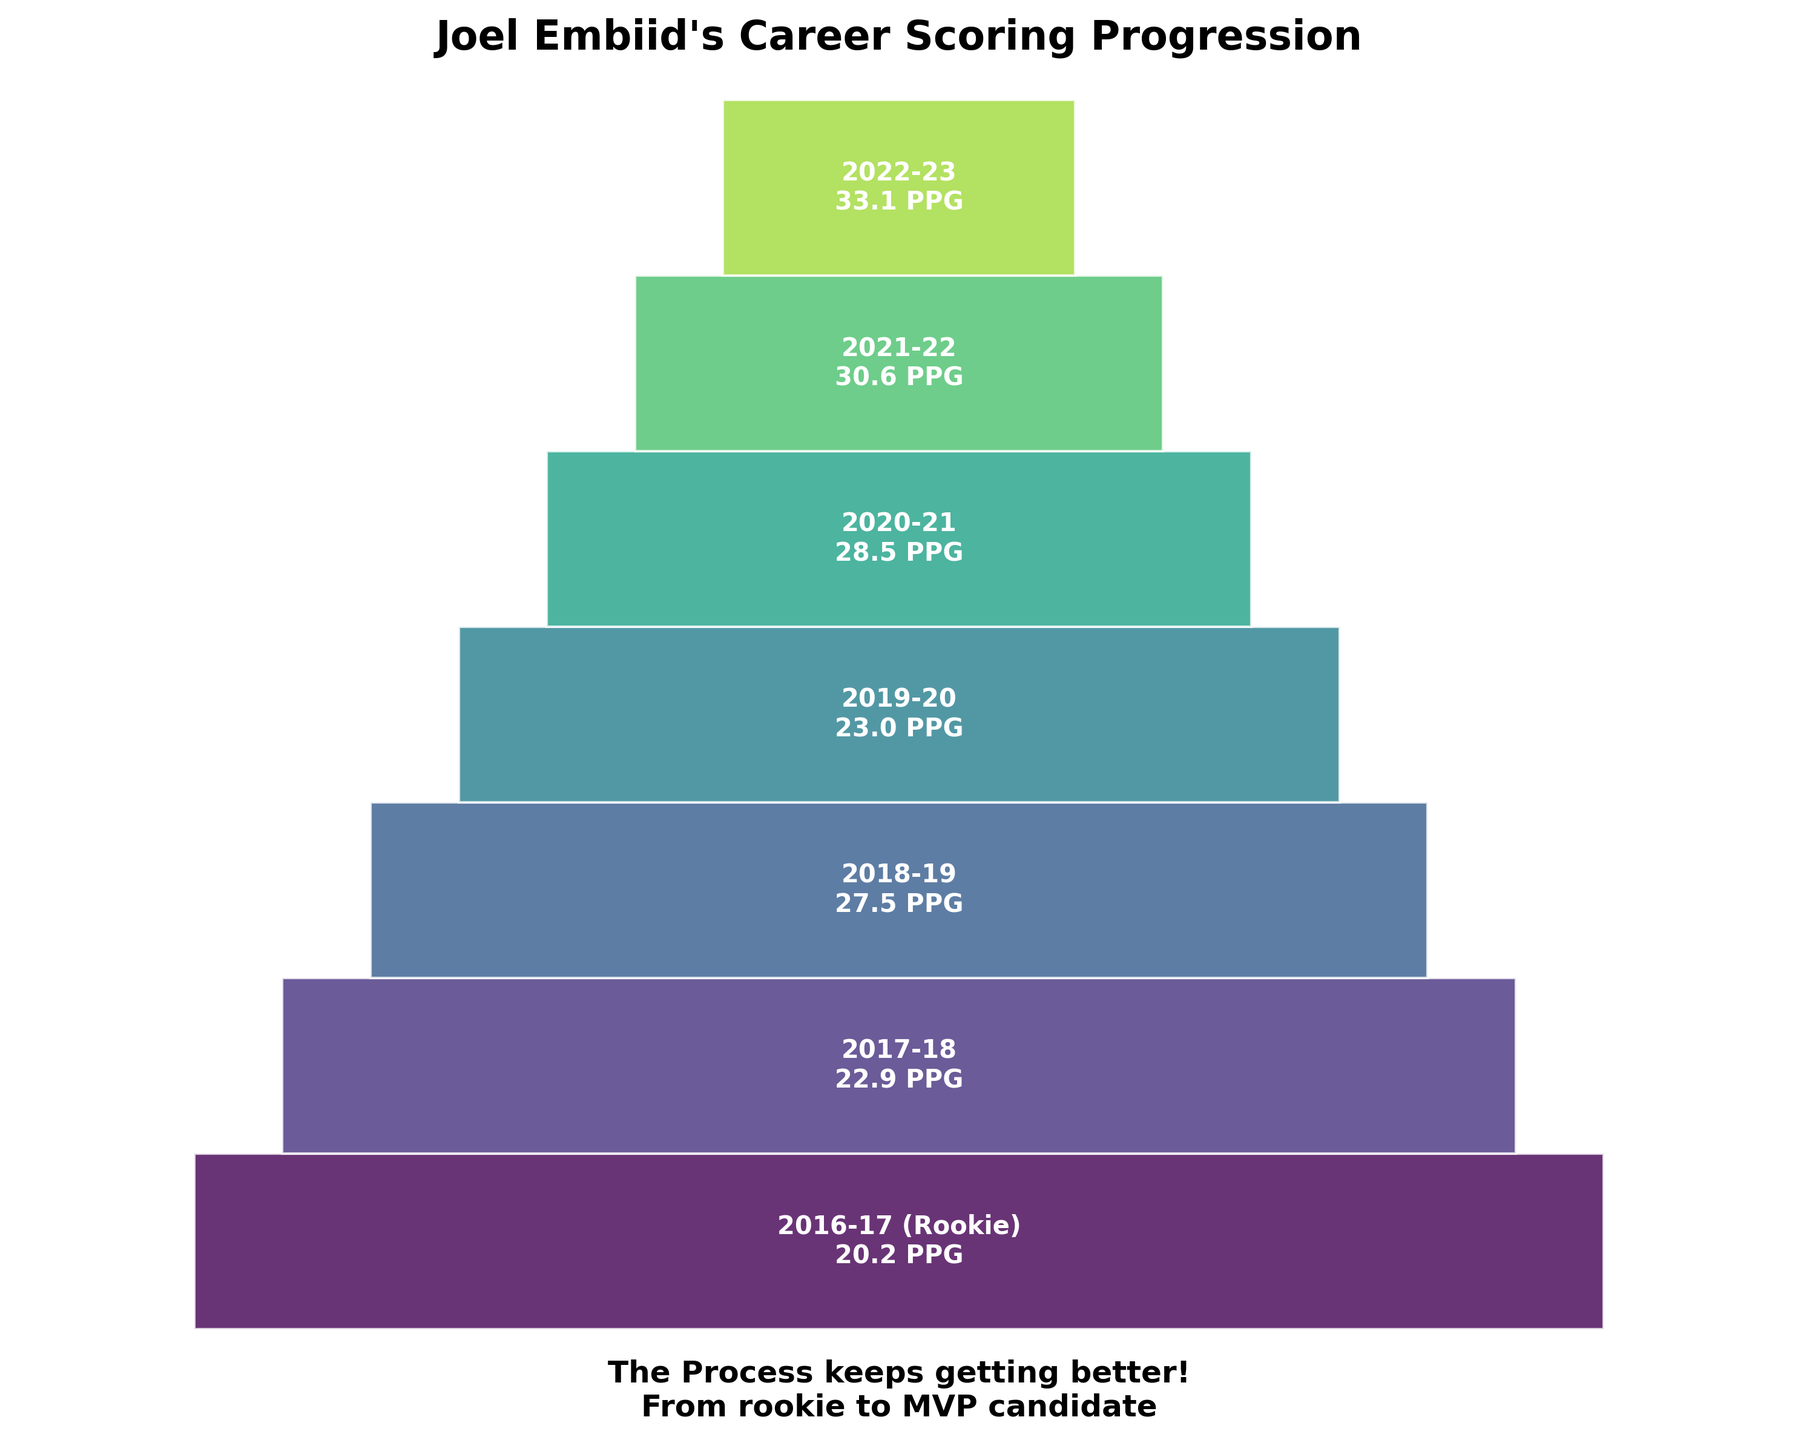How many seasons of Joel Embiid's scoring data are shown in the chart? The chart shows Joel Embiid's points per game (PPG) data for each season from his rookie year to 2022-2023. Counting the number of seasons listed gives us the total number of seasons.
Answer: 7 What is the title of the figure? The title is usually displayed at the top of the figure, providing a summary of what the figure represents. In this case, it refers specifically to Joel Embiid’s career scoring progression.
Answer: Joel Embiid's Career Scoring Progression Which season did Joel Embiid have the highest points per game average? To determine the highest PPG, look for the data point along the vertical axis with the maximum value. The data point labeled "2022-23" has a PPG of 33.1, which is the highest.
Answer: 2022-23 What is the difference in points per game between Joel Embiid's rookie season and the 2022-23 season? Joel Embiid's PPG in his rookie season (2016-17) is 20.2, and in the 2022-23 season, it is 33.1. Subtract the rookie PPG from the 2022-23 PPG: 33.1 - 20.2 = 12.9.
Answer: 12.9 What is the average points per game across all the seasons shown? To find the average PPG, sum all the PPG values and divide by the number of seasons. The PPG values are 20.2, 22.9, 27.5, 23.0, 28.5, 30.6, 33.1. The sum is 185.8. Then, divide by 7 (number of seasons): 185.8 / 7 ≈ 26.54.
Answer: 26.54 What can be inferred about Joel Embiid's scoring trend from the chart? Observing the PPG values for each season, there is a general upward trend with some fluctuations. Starting from 20.2 PPG in his rookie season, increasing with a notable upward trend, climaxing at 33.1 PPG in the latest season.
Answer: Increasing trend How does the 2019-20 season differ visually in the chart compared to the 2018-19 and 2020-21 seasons? The funnel chart visually depicts the values with varying polygon widths. The 2019-20 season (23.0 PPG) has a narrower polygon compared to the 2018-19 (27.5 PPG) and 2020-21 (28.5 PPG) seasons, demonstrating a lower PPG value.
Answer: Narrower polygon 